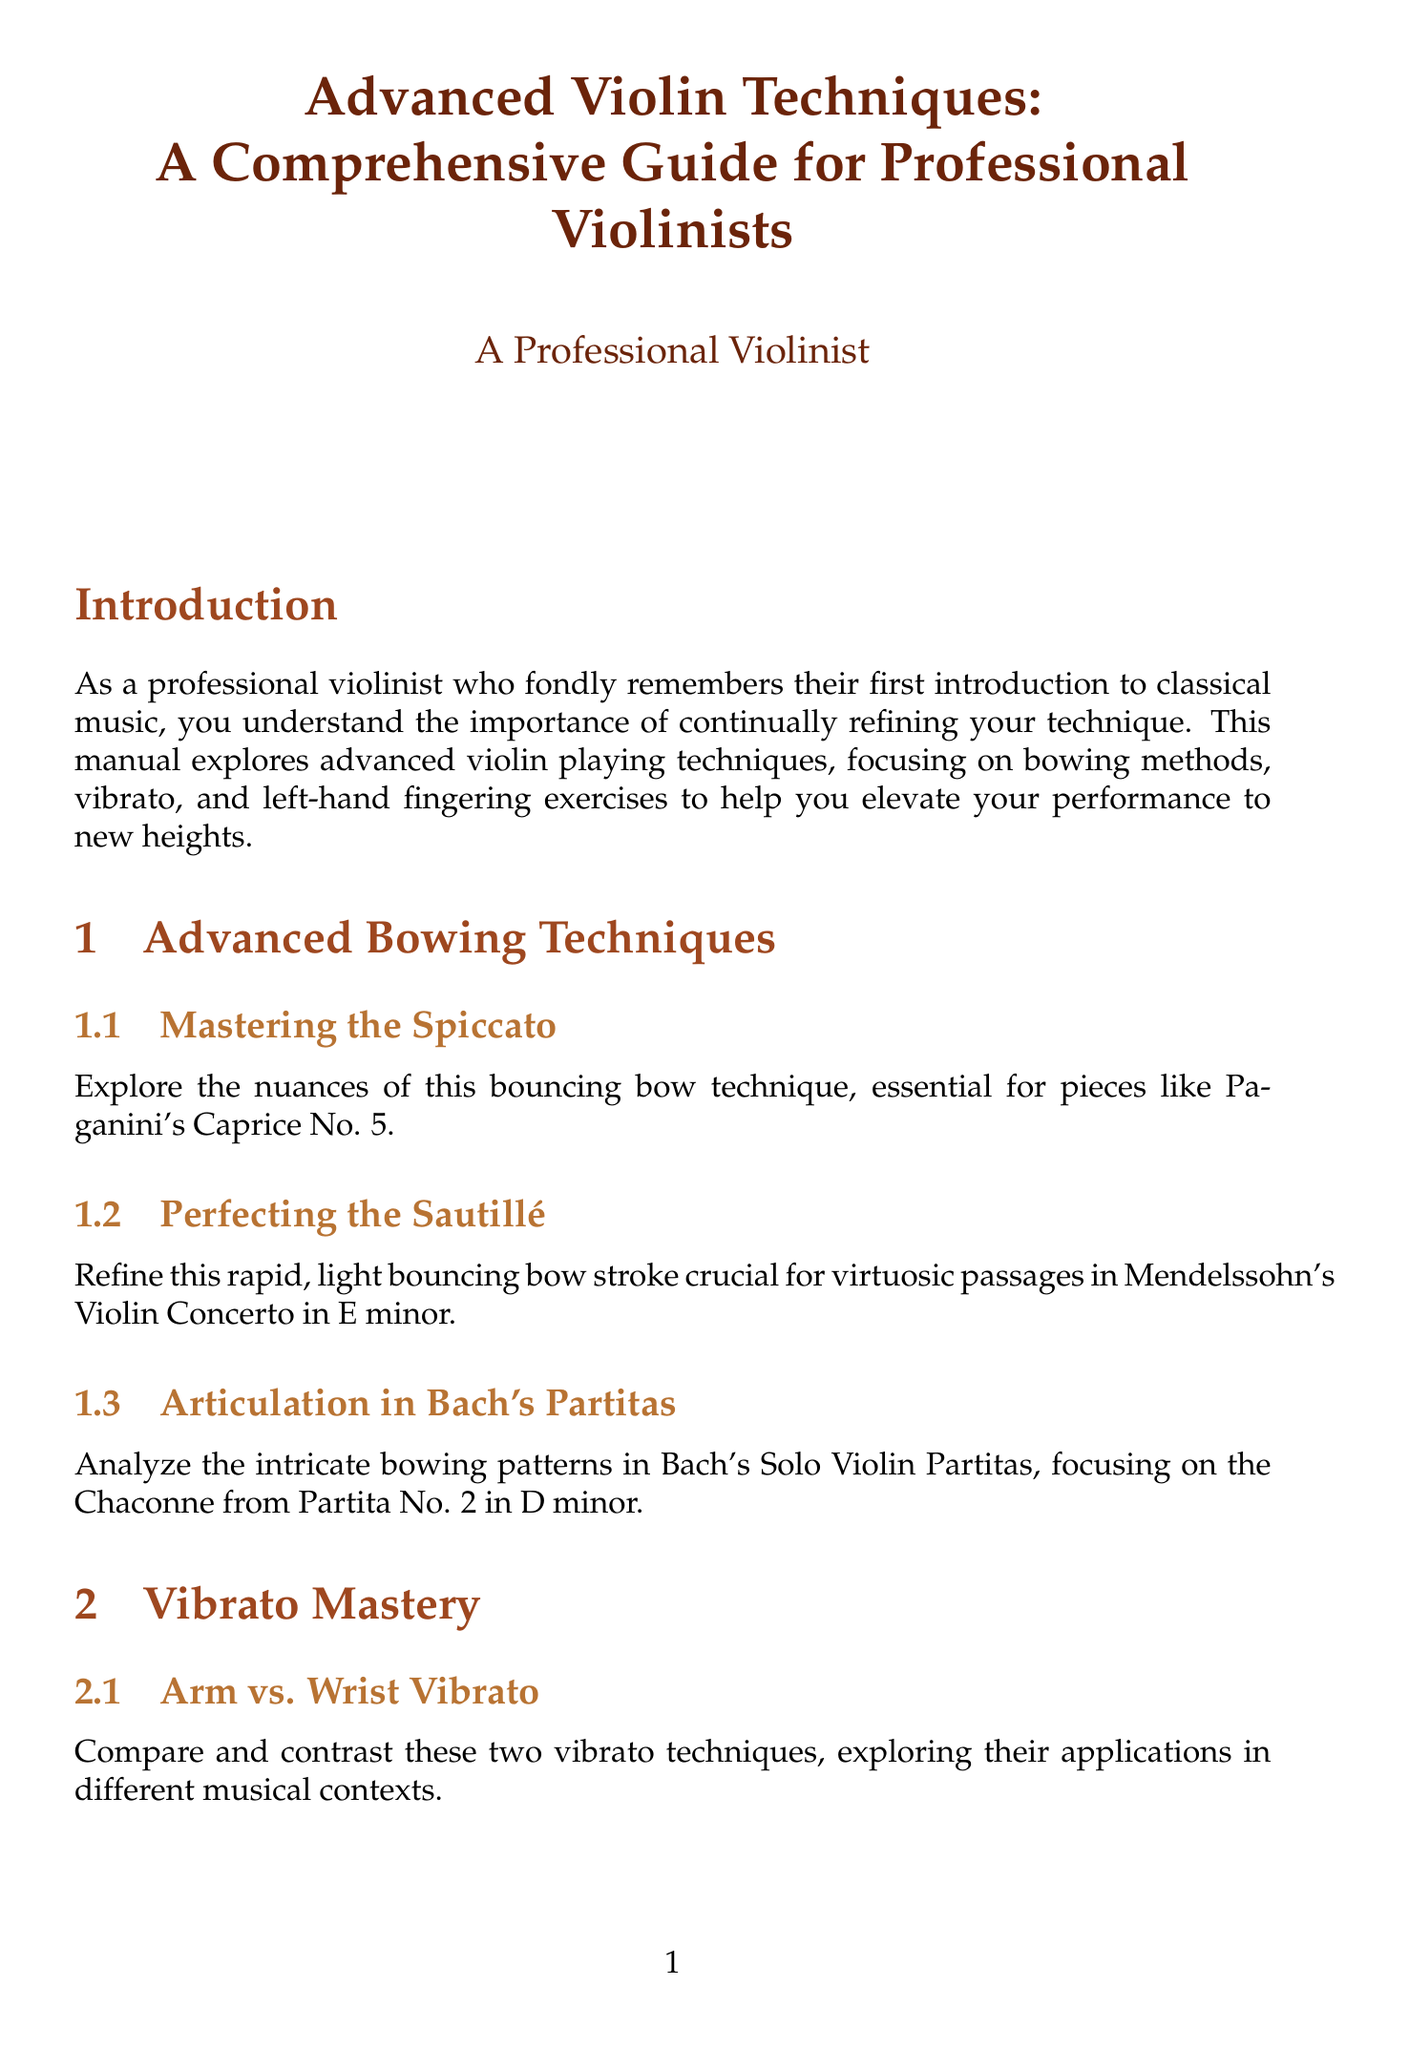What is the title of the manual? The title is clearly stated at the beginning of the document.
Answer: Advanced Violin Techniques: A Comprehensive Guide for Professional Violinists How many chapters are in the manual? The document outlines the chapters clearly, and counting them provides the answer.
Answer: Four What exercise is suggested for improving double-stop precision? The sections provide specific exercises for various techniques, including one for double-stops.
Answer: Exercises inspired by Rodolphe Kreutzer's 42 Studies Which two vibrato techniques are compared? The manual mentions specific techniques in the vibrato section, indicating the two being compared.
Answer: Arm vs. Wrist Vibrato What is the main focus of the chapter titled "Integrating Techniques in Performance"? The title implies a focus area within the chapter, which is explicitly stated.
Answer: Integration of advanced bowing, vibrato, and left-hand techniques Who are some of the recommended violinists for listening? The appendices include a list of notable violinists that serve as examples for advanced techniques.
Answer: Jascha Heifetz, Itzhak Perlman, Hilary Hahn What is the purpose of the conclusion in the manual? The conclusion summarizes the key theme of the manual and offers encouragement.
Answer: To inspire and remind of the joy of music Which piece is analyzed in the case study section? The content specifies a particular work for in-depth examination in the performance section.
Answer: Jean Sibelius' Violin Concerto in D minor 